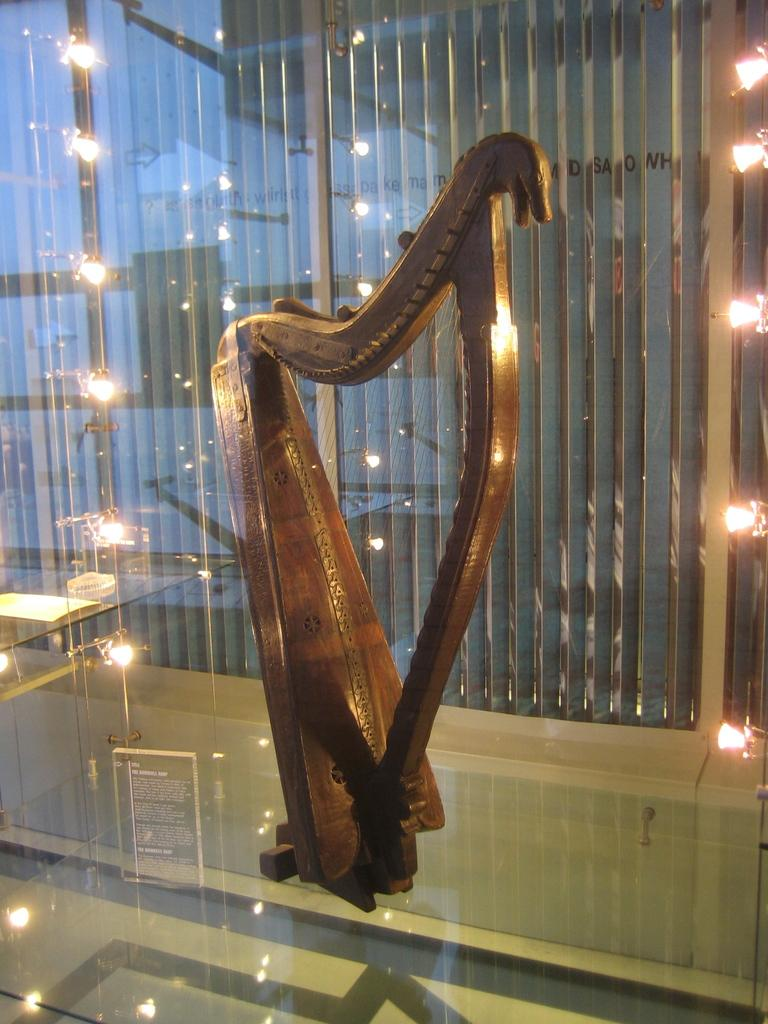What is the main musical instrument in the image? There is a harp in the image. What is the harp resting on? The harp is on a glass object. Can you describe the lighting in the image? There are lights in the image. What other objects can be seen in the image besides the harp and the glass object? There are other objects present in the image. Can you hear the harpist's fang in the image? There is no audible sound in the image, and the concept of a harpist's fang is not applicable. 